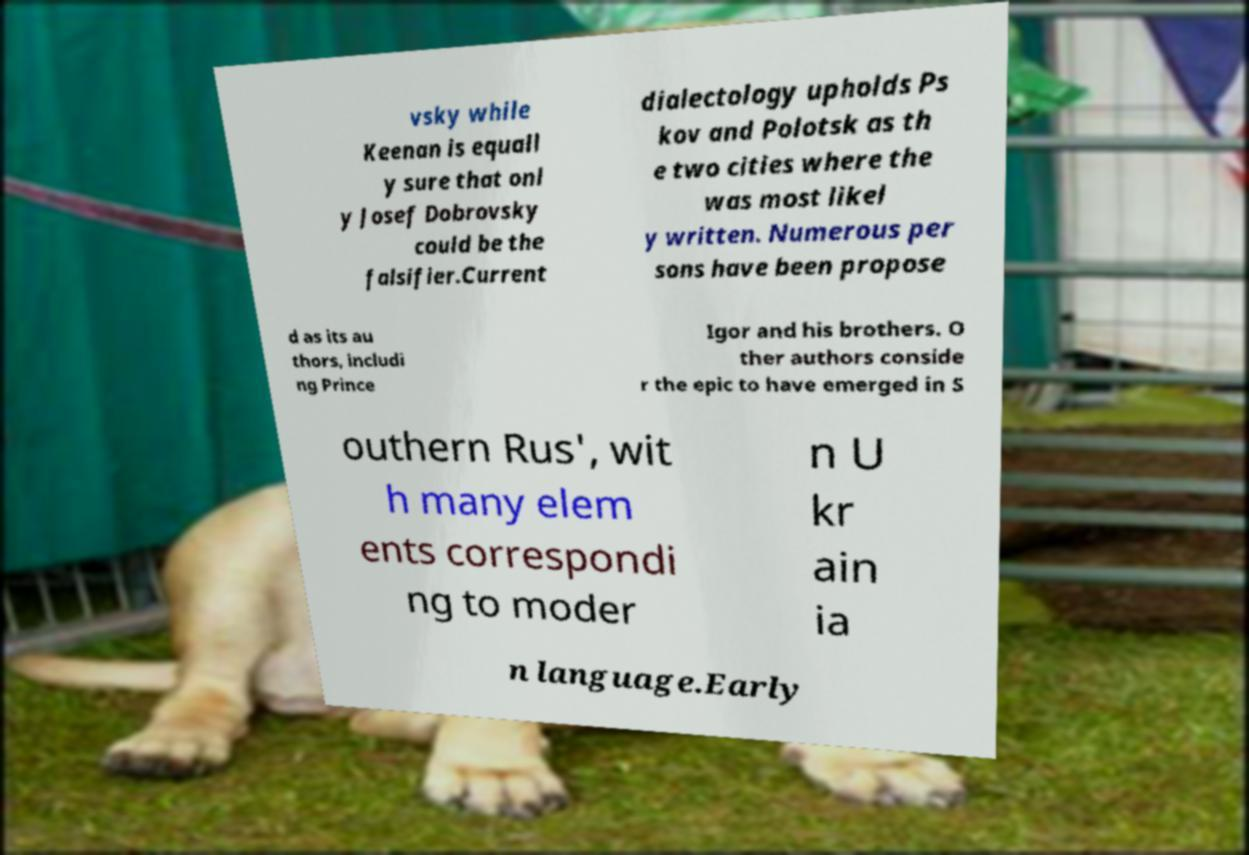Could you extract and type out the text from this image? vsky while Keenan is equall y sure that onl y Josef Dobrovsky could be the falsifier.Current dialectology upholds Ps kov and Polotsk as th e two cities where the was most likel y written. Numerous per sons have been propose d as its au thors, includi ng Prince Igor and his brothers. O ther authors conside r the epic to have emerged in S outhern Rus', wit h many elem ents correspondi ng to moder n U kr ain ia n language.Early 